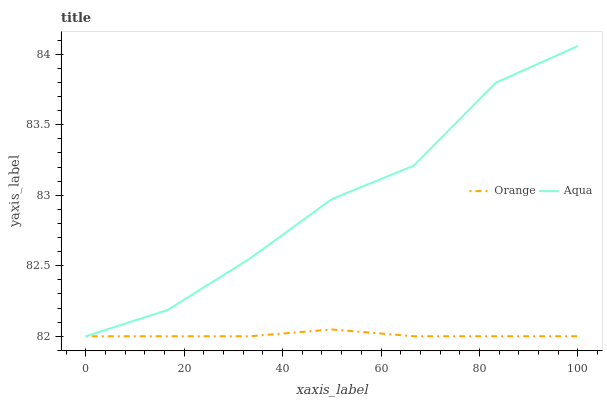Does Orange have the minimum area under the curve?
Answer yes or no. Yes. Does Aqua have the maximum area under the curve?
Answer yes or no. Yes. Does Aqua have the minimum area under the curve?
Answer yes or no. No. Is Orange the smoothest?
Answer yes or no. Yes. Is Aqua the roughest?
Answer yes or no. Yes. Is Aqua the smoothest?
Answer yes or no. No. Does Orange have the lowest value?
Answer yes or no. Yes. Does Aqua have the highest value?
Answer yes or no. Yes. Does Orange intersect Aqua?
Answer yes or no. Yes. Is Orange less than Aqua?
Answer yes or no. No. Is Orange greater than Aqua?
Answer yes or no. No. 